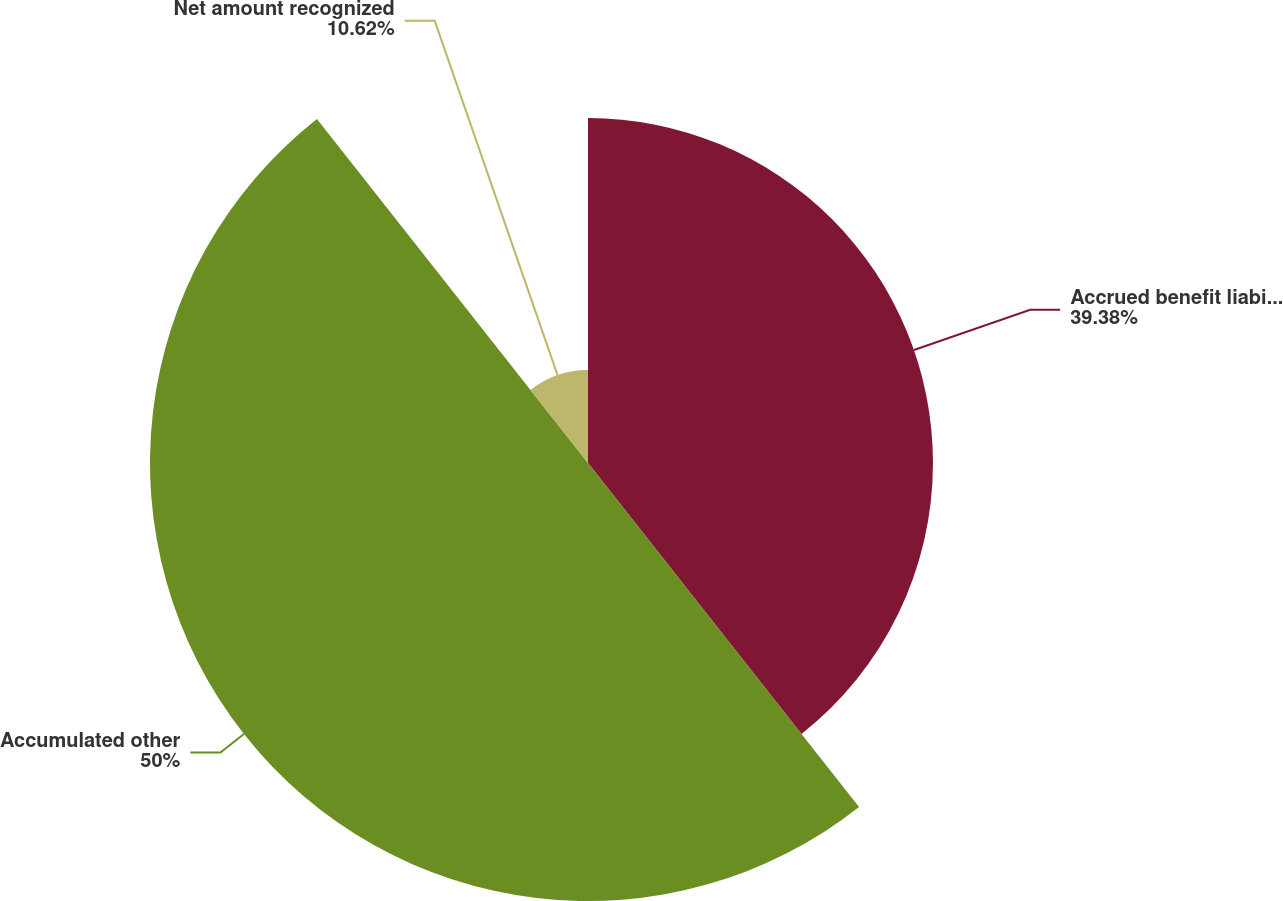<chart> <loc_0><loc_0><loc_500><loc_500><pie_chart><fcel>Accrued benefit liability (2)<fcel>Accumulated other<fcel>Net amount recognized<nl><fcel>39.38%<fcel>50.0%<fcel>10.62%<nl></chart> 